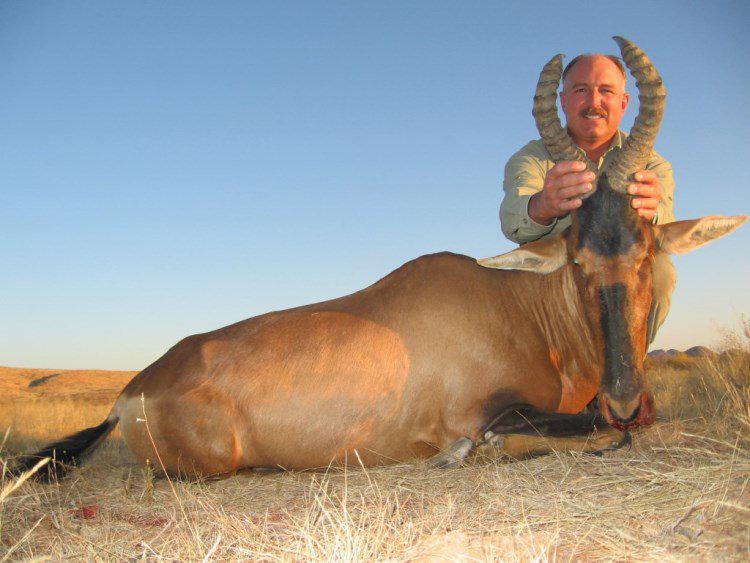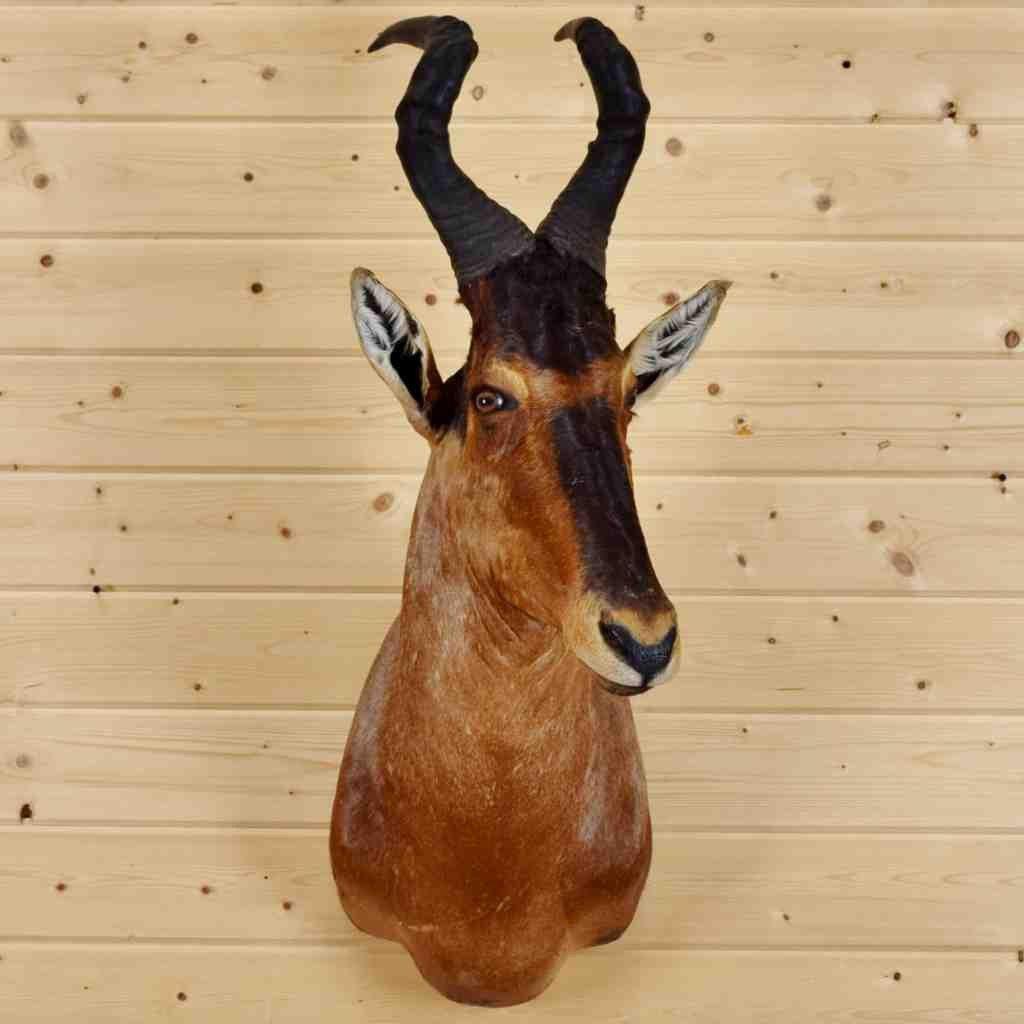The first image is the image on the left, the second image is the image on the right. Considering the images on both sides, is "At least one live ibex is standing in the grass and weeds." valid? Answer yes or no. No. 